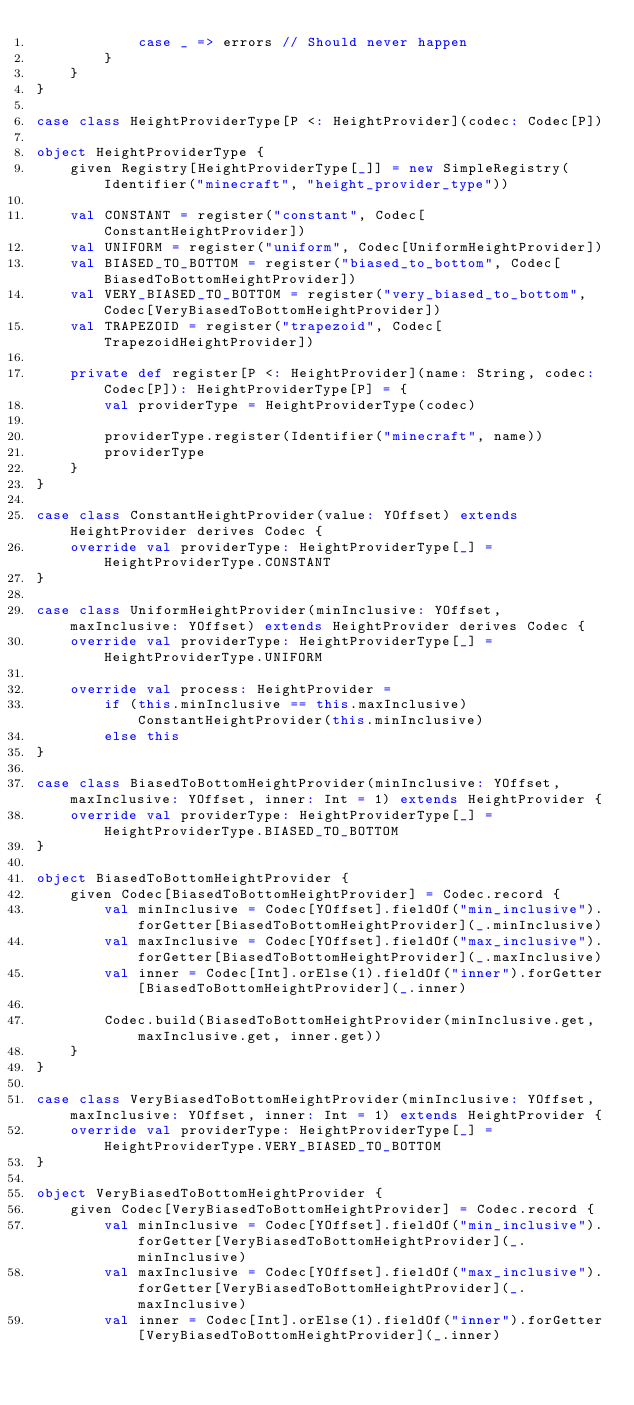Convert code to text. <code><loc_0><loc_0><loc_500><loc_500><_Scala_>            case _ => errors // Should never happen
        }
    }
}

case class HeightProviderType[P <: HeightProvider](codec: Codec[P])

object HeightProviderType {
    given Registry[HeightProviderType[_]] = new SimpleRegistry(Identifier("minecraft", "height_provider_type"))

    val CONSTANT = register("constant", Codec[ConstantHeightProvider])
    val UNIFORM = register("uniform", Codec[UniformHeightProvider])
    val BIASED_TO_BOTTOM = register("biased_to_bottom", Codec[BiasedToBottomHeightProvider])
    val VERY_BIASED_TO_BOTTOM = register("very_biased_to_bottom", Codec[VeryBiasedToBottomHeightProvider])
    val TRAPEZOID = register("trapezoid", Codec[TrapezoidHeightProvider])

    private def register[P <: HeightProvider](name: String, codec: Codec[P]): HeightProviderType[P] = {
        val providerType = HeightProviderType(codec)

        providerType.register(Identifier("minecraft", name))
        providerType
    }
}

case class ConstantHeightProvider(value: YOffset) extends HeightProvider derives Codec {
    override val providerType: HeightProviderType[_] = HeightProviderType.CONSTANT
}

case class UniformHeightProvider(minInclusive: YOffset, maxInclusive: YOffset) extends HeightProvider derives Codec {
    override val providerType: HeightProviderType[_] = HeightProviderType.UNIFORM

    override val process: HeightProvider =
        if (this.minInclusive == this.maxInclusive) ConstantHeightProvider(this.minInclusive)
        else this
}

case class BiasedToBottomHeightProvider(minInclusive: YOffset, maxInclusive: YOffset, inner: Int = 1) extends HeightProvider {
    override val providerType: HeightProviderType[_] = HeightProviderType.BIASED_TO_BOTTOM
}

object BiasedToBottomHeightProvider {
    given Codec[BiasedToBottomHeightProvider] = Codec.record {
        val minInclusive = Codec[YOffset].fieldOf("min_inclusive").forGetter[BiasedToBottomHeightProvider](_.minInclusive)
        val maxInclusive = Codec[YOffset].fieldOf("max_inclusive").forGetter[BiasedToBottomHeightProvider](_.maxInclusive)
        val inner = Codec[Int].orElse(1).fieldOf("inner").forGetter[BiasedToBottomHeightProvider](_.inner)

        Codec.build(BiasedToBottomHeightProvider(minInclusive.get, maxInclusive.get, inner.get))
    }
}

case class VeryBiasedToBottomHeightProvider(minInclusive: YOffset, maxInclusive: YOffset, inner: Int = 1) extends HeightProvider {
    override val providerType: HeightProviderType[_] = HeightProviderType.VERY_BIASED_TO_BOTTOM
}

object VeryBiasedToBottomHeightProvider {
    given Codec[VeryBiasedToBottomHeightProvider] = Codec.record {
        val minInclusive = Codec[YOffset].fieldOf("min_inclusive").forGetter[VeryBiasedToBottomHeightProvider](_.minInclusive)
        val maxInclusive = Codec[YOffset].fieldOf("max_inclusive").forGetter[VeryBiasedToBottomHeightProvider](_.maxInclusive)
        val inner = Codec[Int].orElse(1).fieldOf("inner").forGetter[VeryBiasedToBottomHeightProvider](_.inner)
</code> 